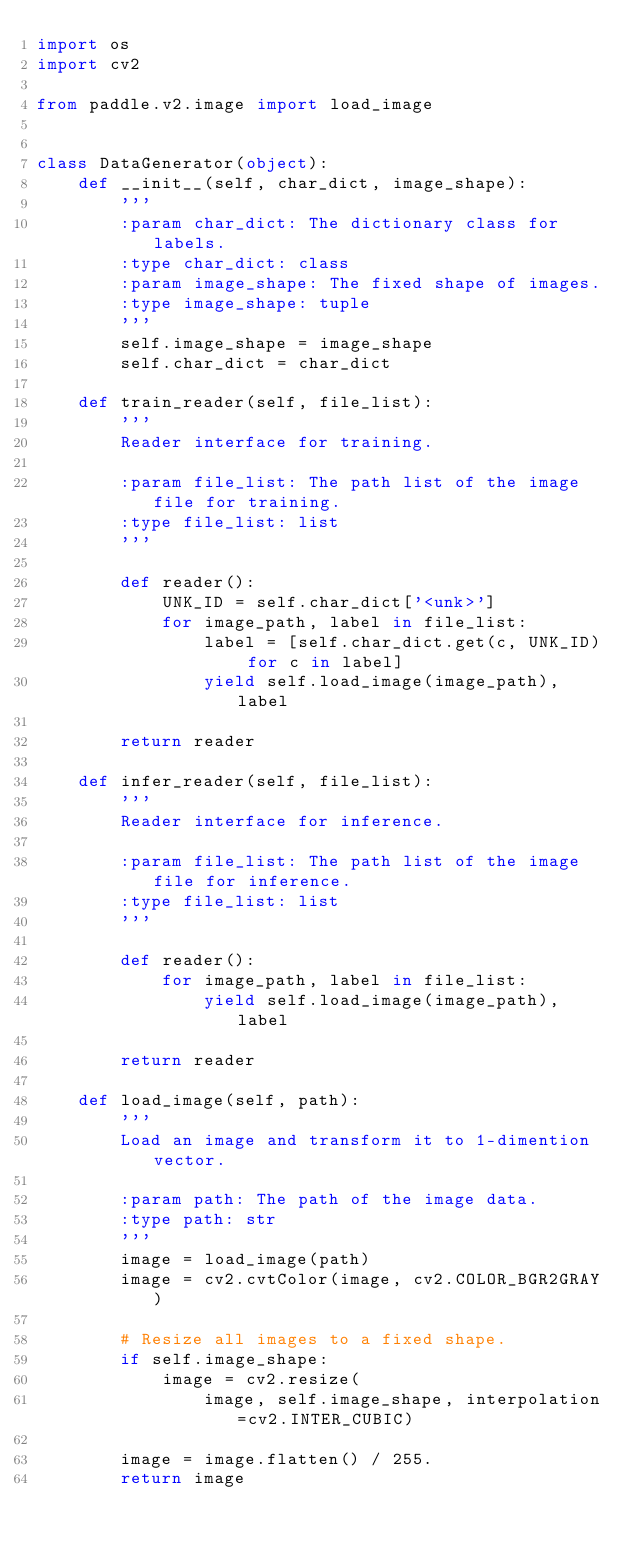<code> <loc_0><loc_0><loc_500><loc_500><_Python_>import os
import cv2

from paddle.v2.image import load_image


class DataGenerator(object):
    def __init__(self, char_dict, image_shape):
        '''
        :param char_dict: The dictionary class for labels.
        :type char_dict: class
        :param image_shape: The fixed shape of images.
        :type image_shape: tuple
        '''
        self.image_shape = image_shape
        self.char_dict = char_dict

    def train_reader(self, file_list):
        '''
        Reader interface for training.

        :param file_list: The path list of the image file for training.
        :type file_list: list
        '''

        def reader():
            UNK_ID = self.char_dict['<unk>']
            for image_path, label in file_list:
                label = [self.char_dict.get(c, UNK_ID) for c in label]
                yield self.load_image(image_path), label

        return reader

    def infer_reader(self, file_list):
        '''
        Reader interface for inference.

        :param file_list: The path list of the image file for inference.
        :type file_list: list
        '''

        def reader():
            for image_path, label in file_list:
                yield self.load_image(image_path), label

        return reader

    def load_image(self, path):
        '''
        Load an image and transform it to 1-dimention vector.

        :param path: The path of the image data.
        :type path: str
        '''
        image = load_image(path)
        image = cv2.cvtColor(image, cv2.COLOR_BGR2GRAY)

        # Resize all images to a fixed shape.
        if self.image_shape:
            image = cv2.resize(
                image, self.image_shape, interpolation=cv2.INTER_CUBIC)

        image = image.flatten() / 255.
        return image
</code> 